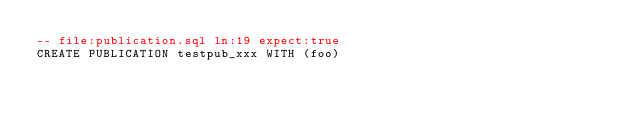Convert code to text. <code><loc_0><loc_0><loc_500><loc_500><_SQL_>-- file:publication.sql ln:19 expect:true
CREATE PUBLICATION testpub_xxx WITH (foo)
</code> 